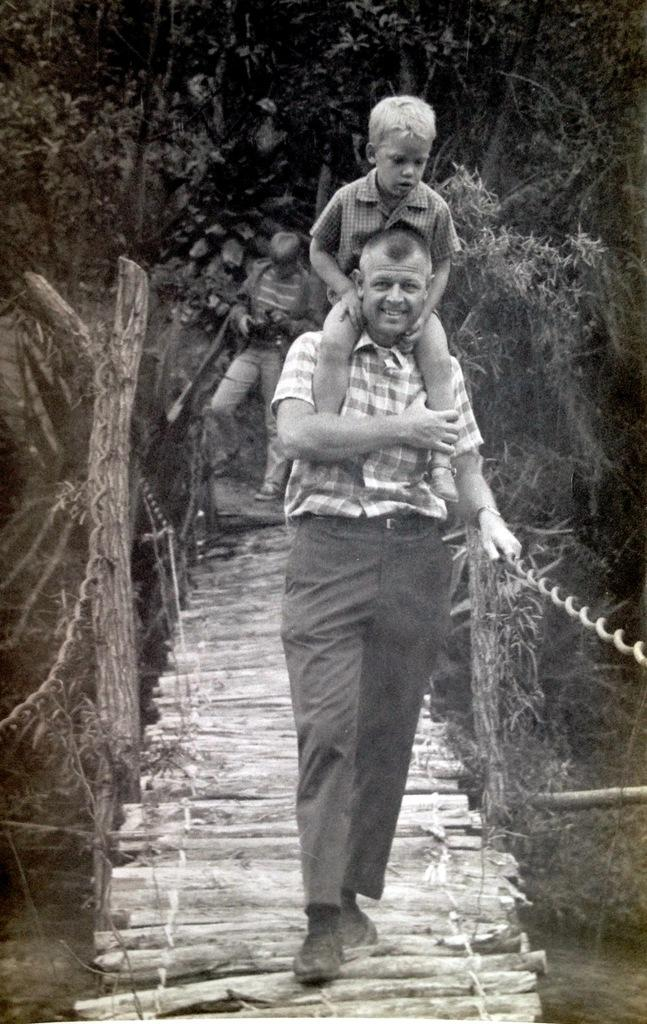What is happening in the image? There is a person holding a child in the image. What are they doing while holding the child? They are walking on wooden logs. What can be seen in the background of the image? There are trees visible in the background. What is the person holding besides the child? The person is holding something, but it is not specified in the facts. What is the color scheme of the image? The image is in black and white. What type of polish is being applied to the knee in the image? There is no mention of polish or a knee in the image; it features a person holding a child while walking on wooden logs. 